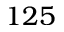<formula> <loc_0><loc_0><loc_500><loc_500>1 2 5</formula> 